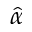Convert formula to latex. <formula><loc_0><loc_0><loc_500><loc_500>\hat { \alpha }</formula> 